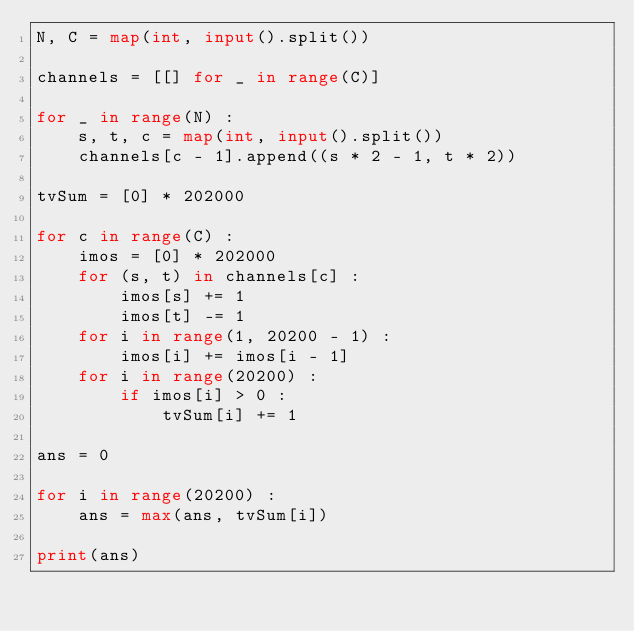<code> <loc_0><loc_0><loc_500><loc_500><_Python_>N, C = map(int, input().split())

channels = [[] for _ in range(C)]

for _ in range(N) :
    s, t, c = map(int, input().split())
    channels[c - 1].append((s * 2 - 1, t * 2))

tvSum = [0] * 202000

for c in range(C) :
    imos = [0] * 202000
    for (s, t) in channels[c] :
        imos[s] += 1
        imos[t] -= 1
    for i in range(1, 20200 - 1) :
        imos[i] += imos[i - 1]
    for i in range(20200) :
        if imos[i] > 0 :
            tvSum[i] += 1

ans = 0

for i in range(20200) :
    ans = max(ans, tvSum[i])

print(ans)</code> 